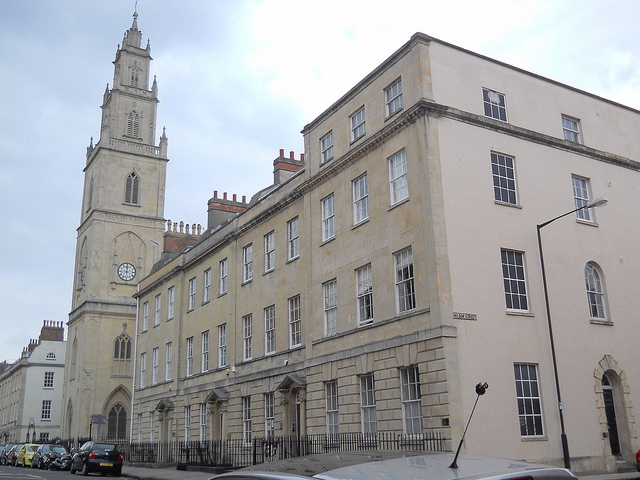How many chimneys can you count on the building? There are a total of six chimneys visible on the building in the image. These chimneys are a notable feature, standing prominently against the sky. Are the chimneys a significant aspect of this architecture? Yes, the chimneys are a significant aspect of this architectural style. In many historical buildings, chimneys not only served practical purposes for ventilation and heating but were also designed to be aesthetically pleasing. Their placement, design, and number often reflect the building's grandeur and the period's architectural norms. 